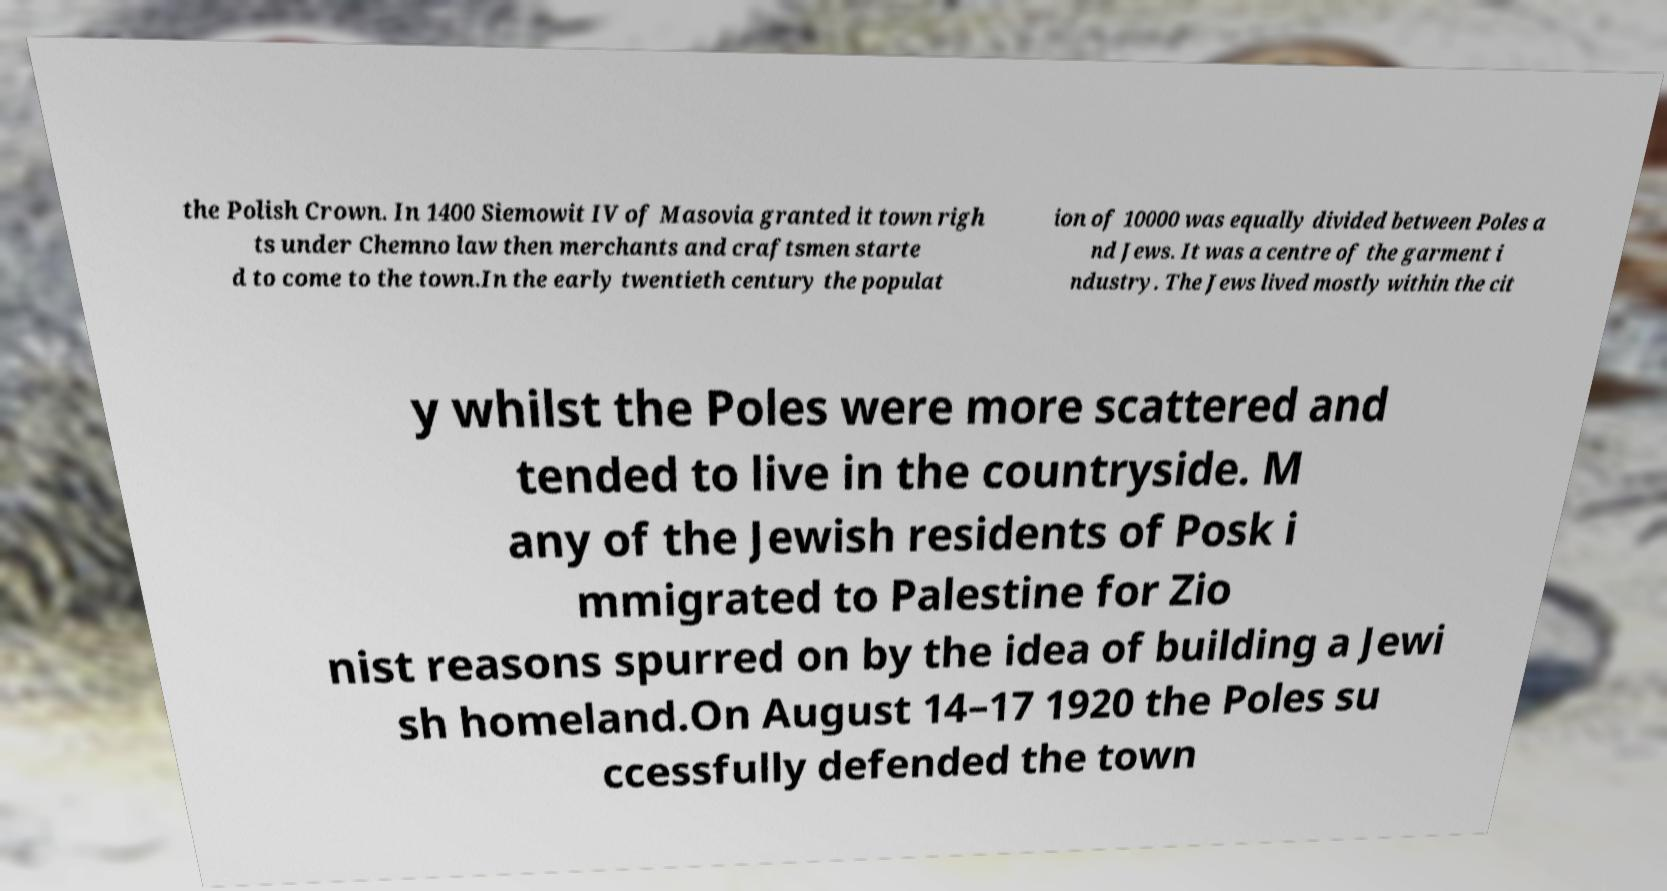Can you read and provide the text displayed in the image?This photo seems to have some interesting text. Can you extract and type it out for me? the Polish Crown. In 1400 Siemowit IV of Masovia granted it town righ ts under Chemno law then merchants and craftsmen starte d to come to the town.In the early twentieth century the populat ion of 10000 was equally divided between Poles a nd Jews. It was a centre of the garment i ndustry. The Jews lived mostly within the cit y whilst the Poles were more scattered and tended to live in the countryside. M any of the Jewish residents of Posk i mmigrated to Palestine for Zio nist reasons spurred on by the idea of building a Jewi sh homeland.On August 14–17 1920 the Poles su ccessfully defended the town 